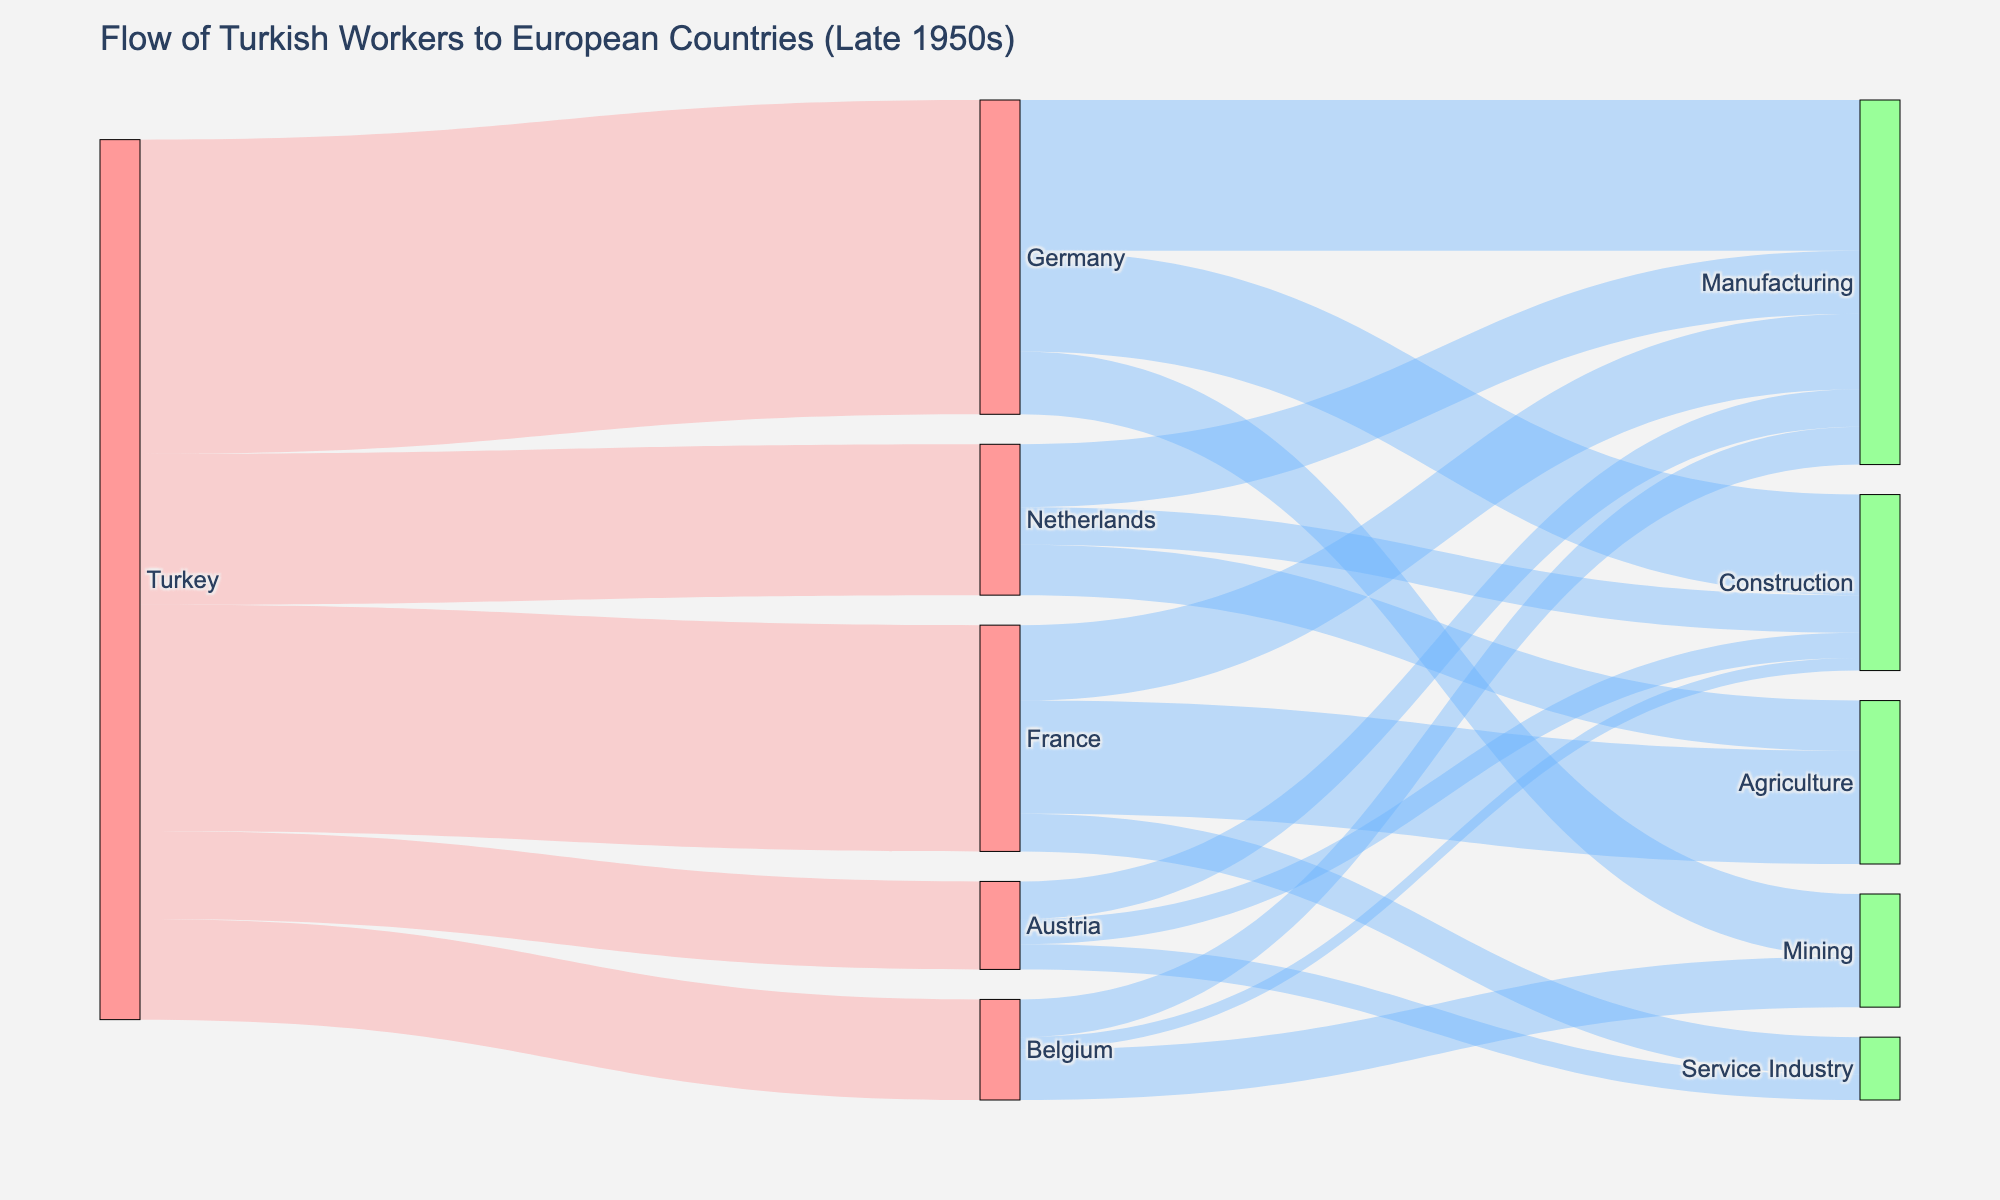What is the title of the figure? The title is typically located at the top of the figure, providing a descriptive heading for the visualized data, which helps in understanding the context and content of the visualization.
Answer: Flow of Turkish Workers to European Countries (Late 1950s) What color represents the target countries in the figure? The node colors help differentiate between the source, target countries, and occupations. From the description, target countries are marked in blue.
Answer: Blue How many Turkish workers went to Germany in the late 1950s? By examining the link from Turkey to Germany, we can identify the number of workers by the value associated with the link.
Answer: 25,000 Which occupation in Germany received the highest number of Turkish workers? By following the links from Germany to its respective occupational nodes, we can compare the values and identify which occupation received the most workers.
Answer: Manufacturing What is the total number of Turkish workers who went to the Netherlands, Belgium, and Austria combined? To get the combined total, sum the values for each destination country. For the Netherlands (12,000), Belgium (8,000), and Austria (7,000), sum these values: 12,000 + 8,000 + 7,000 = 27,000
Answer: 27,000 How does the flow of Turkish workers to the service industry in Austria compare to that in France? Compare the values for the links indicating the number of workers going to the service industry in both countries. Austria has 2,000, and France has 3,000.
Answer: France has more workers in the service industry What occupation in Belgium received the least number of Turkish workers? By comparing the values of the links from Belgium to the occupations, the lowest value represents the occupation receiving the least workers, which is Construction (1,000).
Answer: Construction How many total workers were involved in manufacturing across all destination countries? Sum the values of workers in manufacturing for each target country: Germany (12,000), France (6,000), Netherlands (5,000), Belgium (3,000), and Austria (3,000). Total = 12,000 + 6,000 + 5,000 + 3,000 + 3,000 = 29,000
Answer: 29,000 Which destination country received the second highest number of Turkish workers? By comparing the link values from Turkey to each target country, we find that France is second after Germany with 18,000 workers.
Answer: France (18,000) How many Turkish workers went into the construction sector across all the countries? Sum the values of Turkish workers in the construction sector for Germany (8,000), Netherlands (3,000), Belgium (1,000), and Austria (2,000): 8,000 + 3,000 + 1,000 + 2,000 = 14,000
Answer: 14,000 